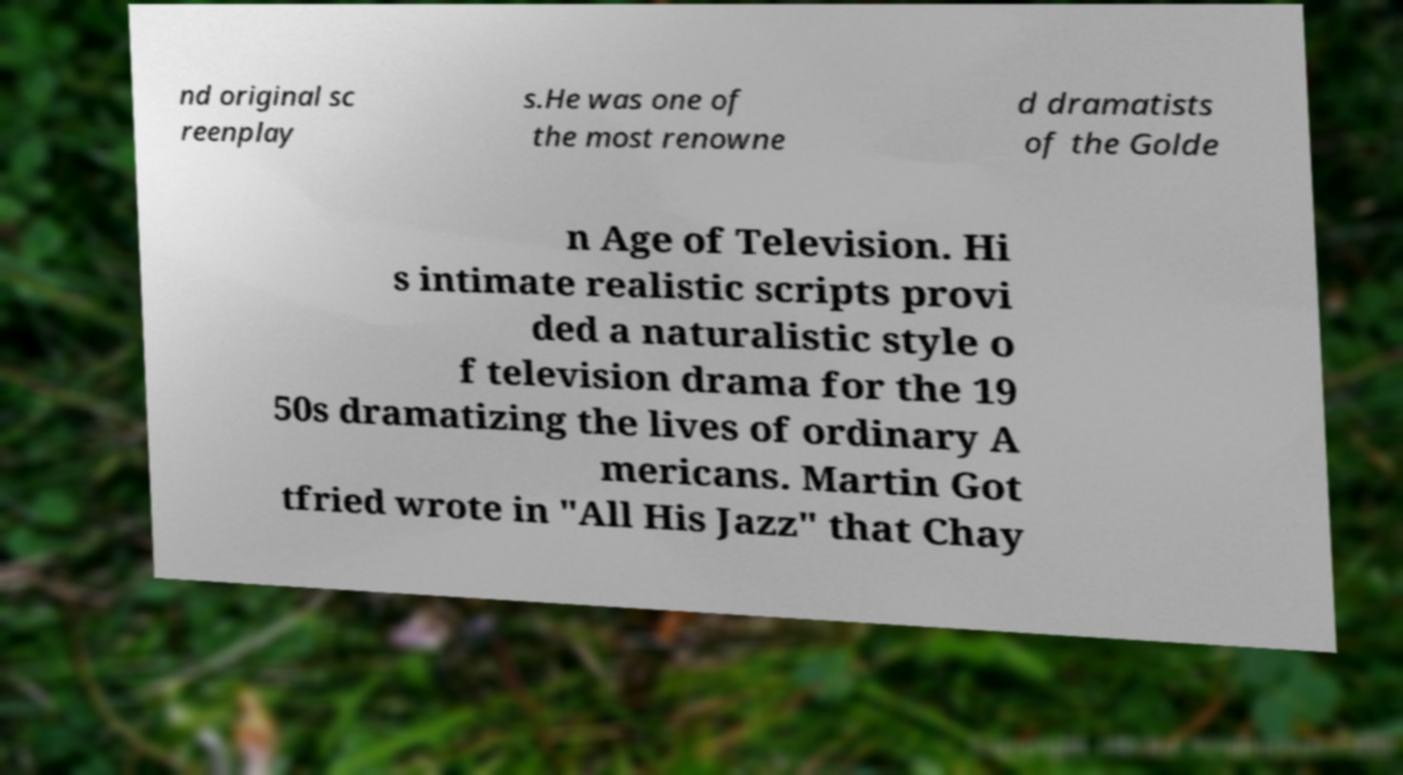What messages or text are displayed in this image? I need them in a readable, typed format. nd original sc reenplay s.He was one of the most renowne d dramatists of the Golde n Age of Television. Hi s intimate realistic scripts provi ded a naturalistic style o f television drama for the 19 50s dramatizing the lives of ordinary A mericans. Martin Got tfried wrote in "All His Jazz" that Chay 